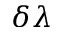<formula> <loc_0><loc_0><loc_500><loc_500>\delta \lambda</formula> 